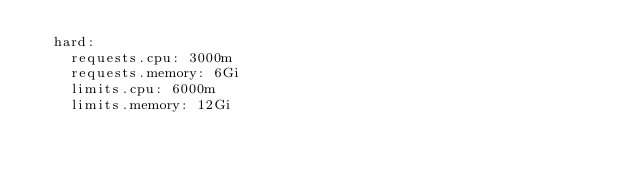<code> <loc_0><loc_0><loc_500><loc_500><_YAML_>  hard:
    requests.cpu: 3000m
    requests.memory: 6Gi
    limits.cpu: 6000m
    limits.memory: 12Gi
</code> 